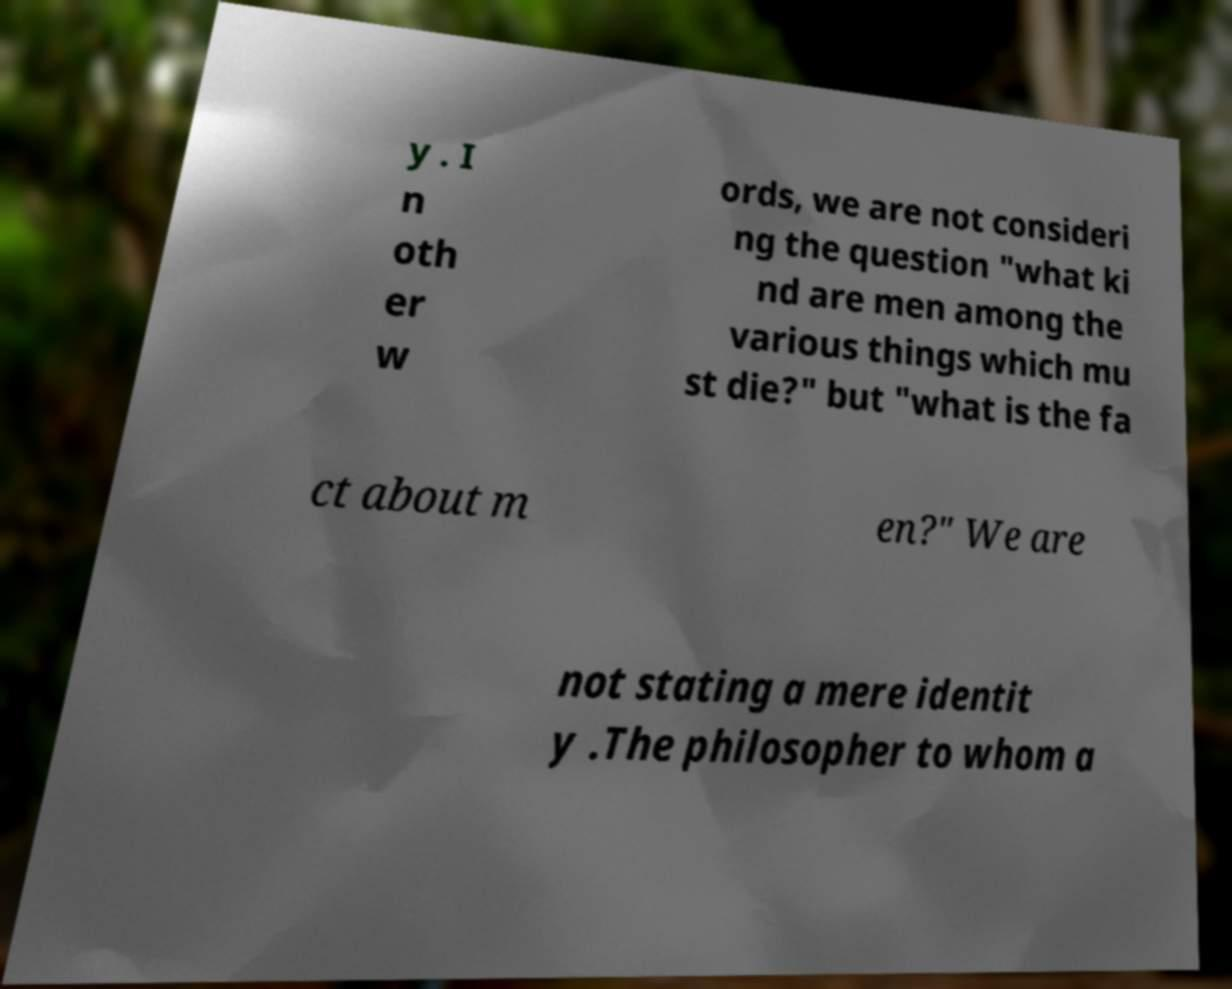There's text embedded in this image that I need extracted. Can you transcribe it verbatim? y . I n oth er w ords, we are not consideri ng the question "what ki nd are men among the various things which mu st die?" but "what is the fa ct about m en?" We are not stating a mere identit y .The philosopher to whom a 